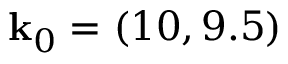Convert formula to latex. <formula><loc_0><loc_0><loc_500><loc_500>k _ { 0 } = ( 1 0 , 9 . 5 )</formula> 